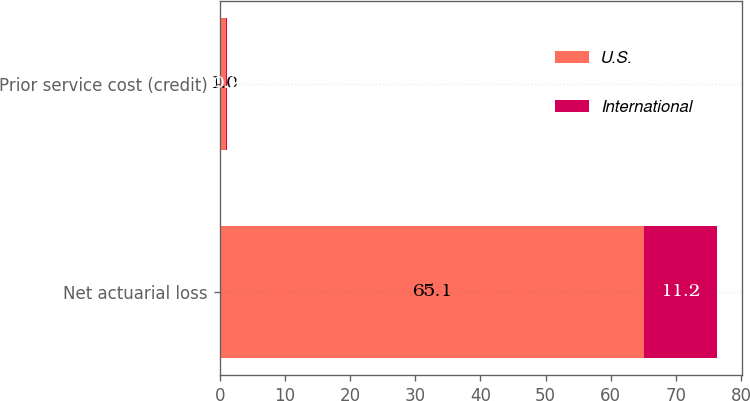Convert chart. <chart><loc_0><loc_0><loc_500><loc_500><stacked_bar_chart><ecel><fcel>Net actuarial loss<fcel>Prior service cost (credit)<nl><fcel>U.S.<fcel>65.1<fcel>1<nl><fcel>International<fcel>11.2<fcel>0.2<nl></chart> 